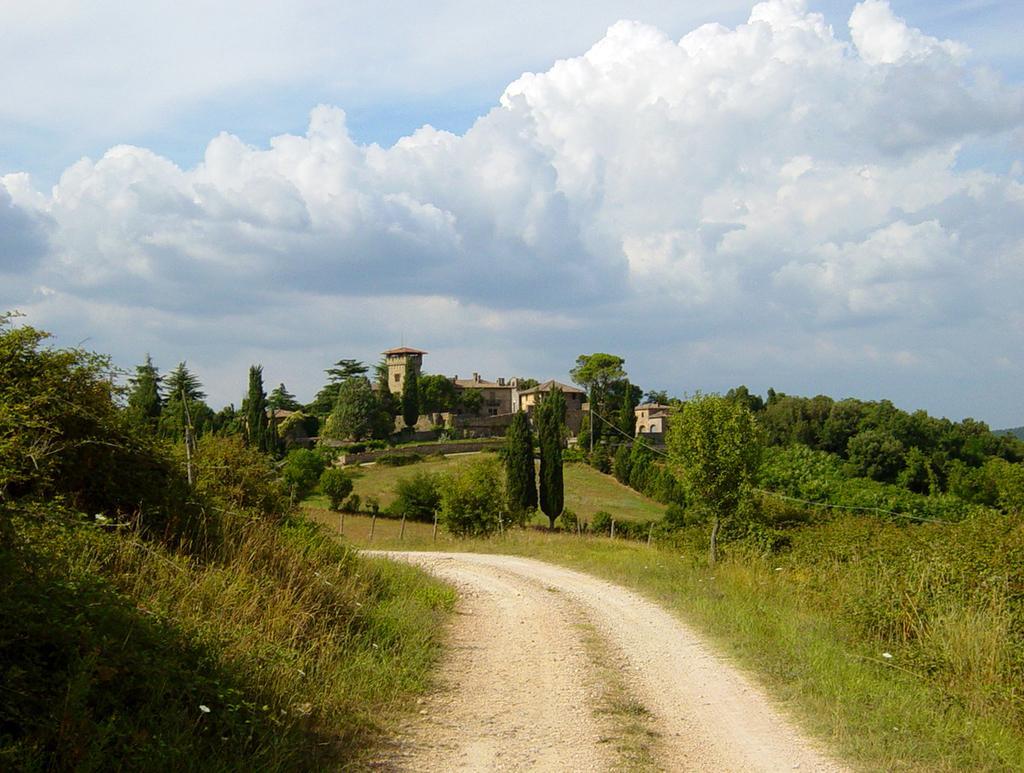How would you summarize this image in a sentence or two? In this picture we can see a path, beside this path we can see trees, fence, buildings, poles and in the background we can see sky with clouds. 